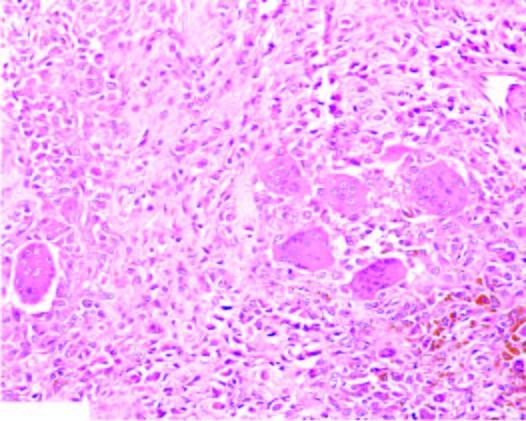does the wall of the gallbladder show infiltrate of small oval to spindled histiocytes with numerous interspersed multinucleate giant cells lyning in a background of fibrous tissue?
Answer the question using a single word or phrase. No 